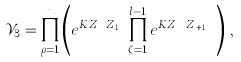<formula> <loc_0><loc_0><loc_500><loc_500>\mathcal { V } _ { 3 } = \prod _ { \rho = 1 } ^ { m } \left ( e ^ { K Z _ { \rho , l } Z _ { \rho , 1 } } \prod _ { \zeta = 1 } ^ { l - 1 } e ^ { K Z _ { \rho , \zeta } Z _ { \rho , \zeta + 1 } } \right ) \, ,</formula> 